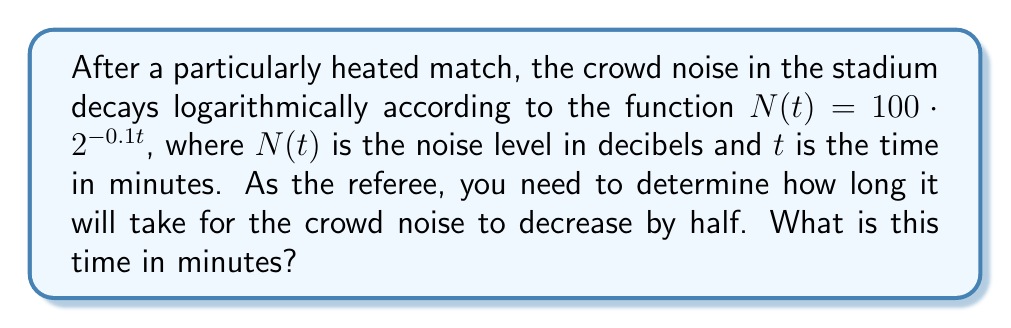Solve this math problem. Let's approach this step-by-step:

1) We need to find $t$ when $N(t)$ is half of its initial value.

2) Initial value: $N(0) = 100 \cdot 2^{-0.1 \cdot 0} = 100$ decibels

3) We want to find $t$ when $N(t) = 50$ decibels (half of 100)

4) Set up the equation:
   $50 = 100 \cdot 2^{-0.1t}$

5) Divide both sides by 100:
   $\frac{1}{2} = 2^{-0.1t}$

6) Take the logarithm (base 2) of both sides:
   $\log_2(\frac{1}{2}) = \log_2(2^{-0.1t})$

7) Simplify the right side using logarithm properties:
   $\log_2(\frac{1}{2}) = -0.1t \cdot \log_2(2) = -0.1t$

8) Simplify the left side:
   $-1 = -0.1t$

9) Solve for $t$:
   $t = \frac{-1}{-0.1} = 10$

Therefore, it will take 10 minutes for the crowd noise to decrease by half.
Answer: 10 minutes 